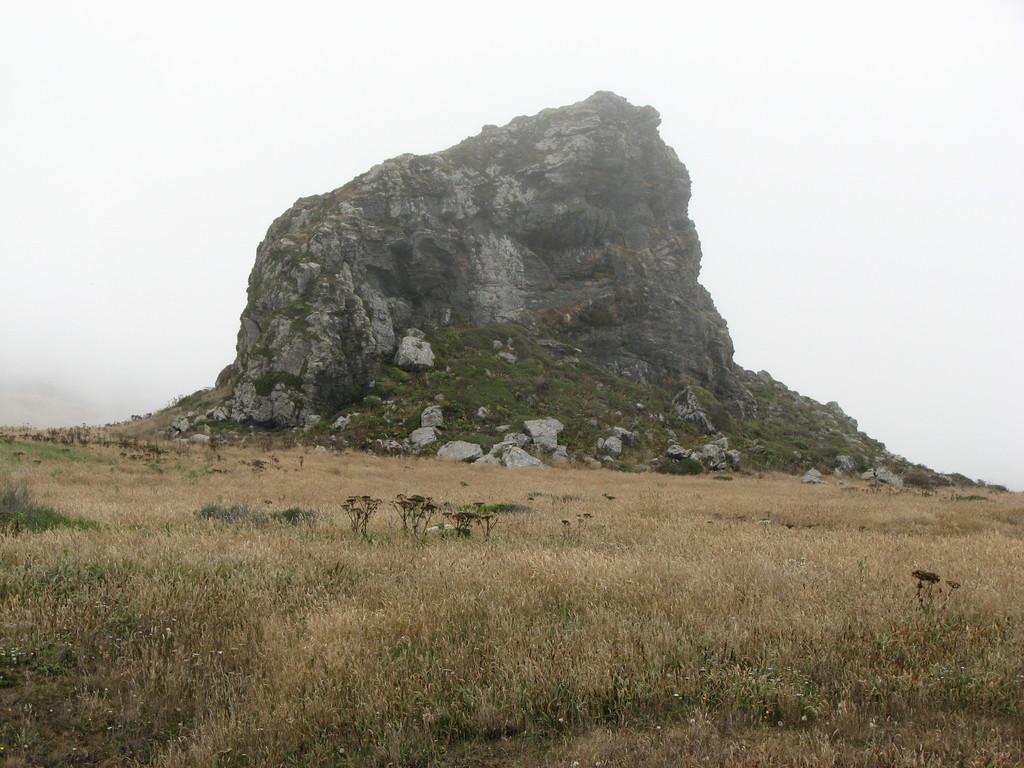Can you describe this image briefly? In this image there is grass, plants, hill, and in the background there is sky. 